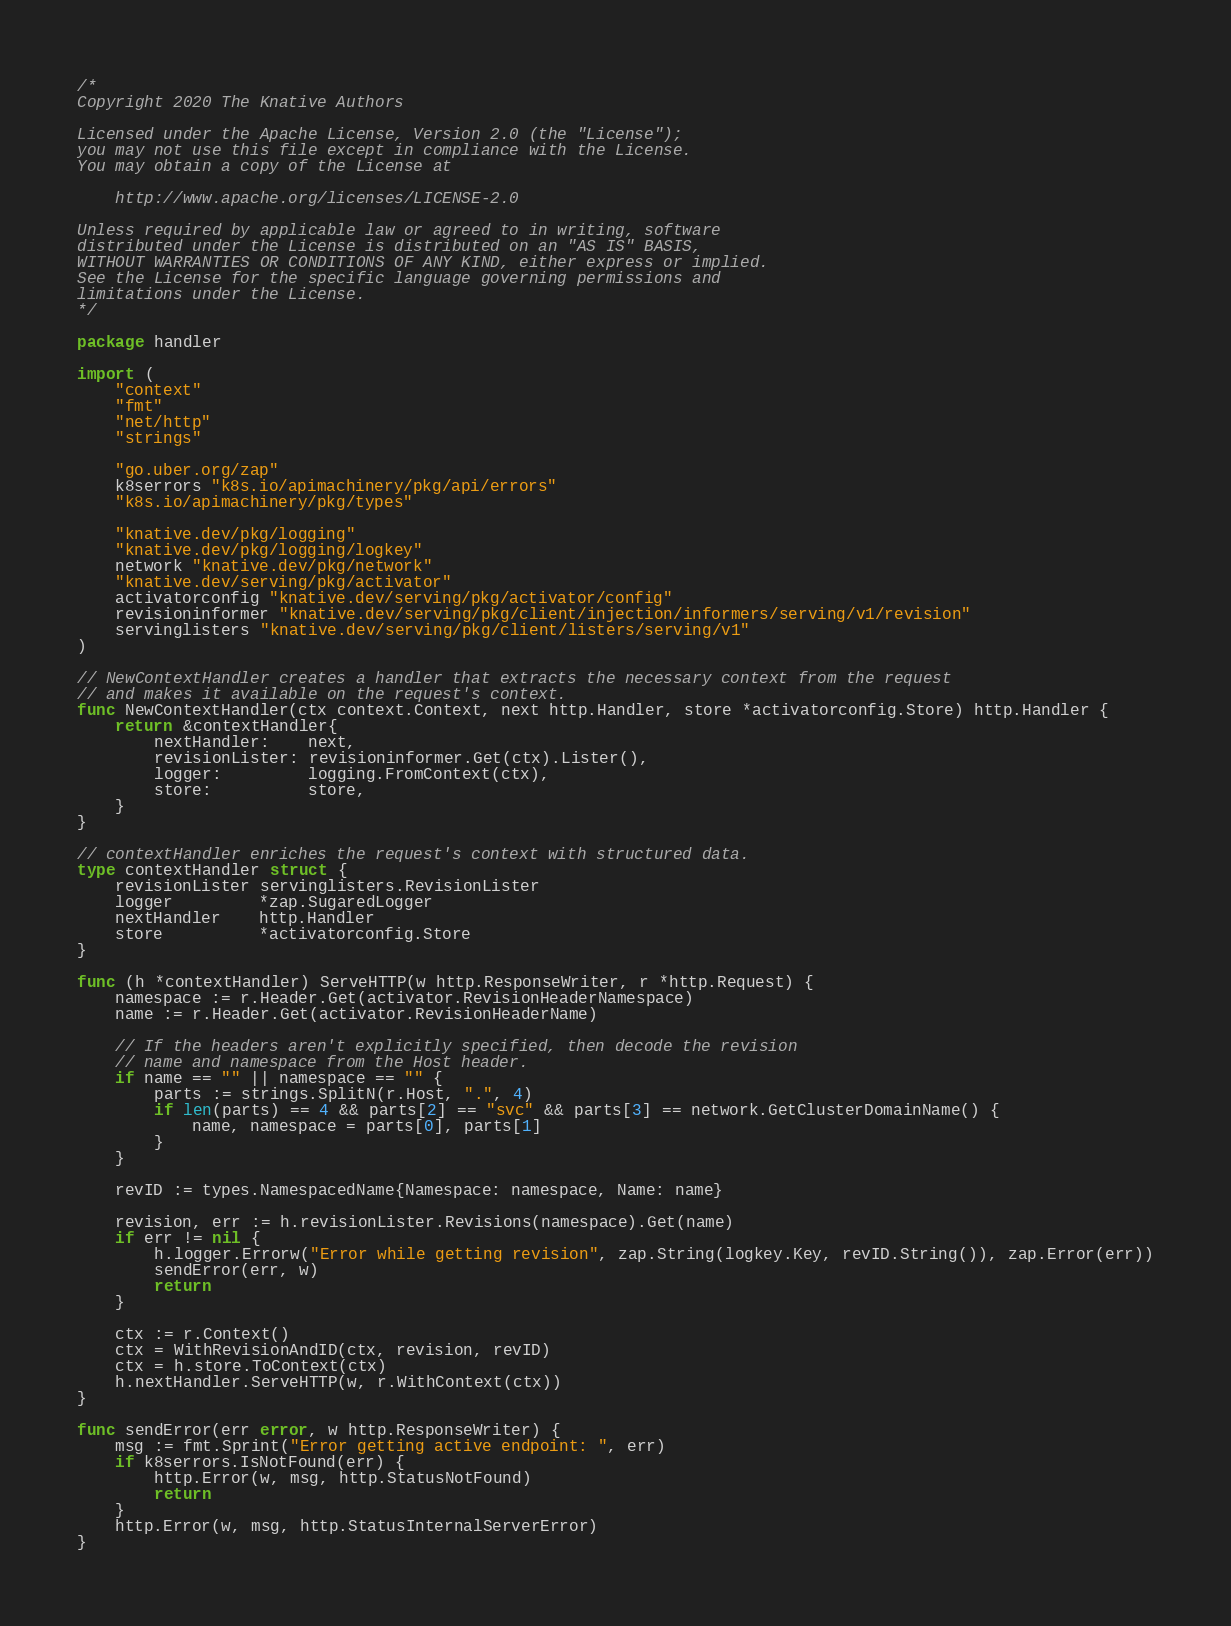<code> <loc_0><loc_0><loc_500><loc_500><_Go_>/*
Copyright 2020 The Knative Authors

Licensed under the Apache License, Version 2.0 (the "License");
you may not use this file except in compliance with the License.
You may obtain a copy of the License at

    http://www.apache.org/licenses/LICENSE-2.0

Unless required by applicable law or agreed to in writing, software
distributed under the License is distributed on an "AS IS" BASIS,
WITHOUT WARRANTIES OR CONDITIONS OF ANY KIND, either express or implied.
See the License for the specific language governing permissions and
limitations under the License.
*/

package handler

import (
	"context"
	"fmt"
	"net/http"
	"strings"

	"go.uber.org/zap"
	k8serrors "k8s.io/apimachinery/pkg/api/errors"
	"k8s.io/apimachinery/pkg/types"

	"knative.dev/pkg/logging"
	"knative.dev/pkg/logging/logkey"
	network "knative.dev/pkg/network"
	"knative.dev/serving/pkg/activator"
	activatorconfig "knative.dev/serving/pkg/activator/config"
	revisioninformer "knative.dev/serving/pkg/client/injection/informers/serving/v1/revision"
	servinglisters "knative.dev/serving/pkg/client/listers/serving/v1"
)

// NewContextHandler creates a handler that extracts the necessary context from the request
// and makes it available on the request's context.
func NewContextHandler(ctx context.Context, next http.Handler, store *activatorconfig.Store) http.Handler {
	return &contextHandler{
		nextHandler:    next,
		revisionLister: revisioninformer.Get(ctx).Lister(),
		logger:         logging.FromContext(ctx),
		store:          store,
	}
}

// contextHandler enriches the request's context with structured data.
type contextHandler struct {
	revisionLister servinglisters.RevisionLister
	logger         *zap.SugaredLogger
	nextHandler    http.Handler
	store          *activatorconfig.Store
}

func (h *contextHandler) ServeHTTP(w http.ResponseWriter, r *http.Request) {
	namespace := r.Header.Get(activator.RevisionHeaderNamespace)
	name := r.Header.Get(activator.RevisionHeaderName)

	// If the headers aren't explicitly specified, then decode the revision
	// name and namespace from the Host header.
	if name == "" || namespace == "" {
		parts := strings.SplitN(r.Host, ".", 4)
		if len(parts) == 4 && parts[2] == "svc" && parts[3] == network.GetClusterDomainName() {
			name, namespace = parts[0], parts[1]
		}
	}

	revID := types.NamespacedName{Namespace: namespace, Name: name}

	revision, err := h.revisionLister.Revisions(namespace).Get(name)
	if err != nil {
		h.logger.Errorw("Error while getting revision", zap.String(logkey.Key, revID.String()), zap.Error(err))
		sendError(err, w)
		return
	}

	ctx := r.Context()
	ctx = WithRevisionAndID(ctx, revision, revID)
	ctx = h.store.ToContext(ctx)
	h.nextHandler.ServeHTTP(w, r.WithContext(ctx))
}

func sendError(err error, w http.ResponseWriter) {
	msg := fmt.Sprint("Error getting active endpoint: ", err)
	if k8serrors.IsNotFound(err) {
		http.Error(w, msg, http.StatusNotFound)
		return
	}
	http.Error(w, msg, http.StatusInternalServerError)
}
</code> 